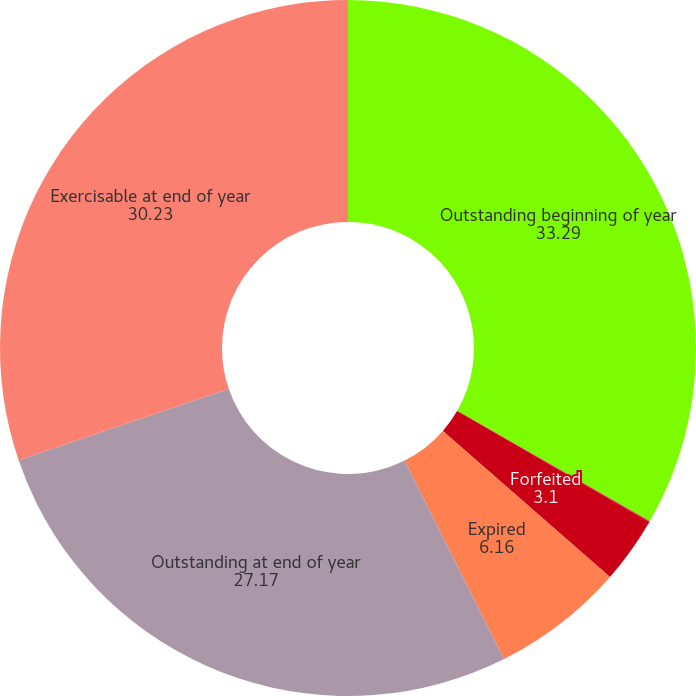<chart> <loc_0><loc_0><loc_500><loc_500><pie_chart><fcel>Outstanding beginning of year<fcel>Exercised<fcel>Forfeited<fcel>Expired<fcel>Outstanding at end of year<fcel>Exercisable at end of year<nl><fcel>33.29%<fcel>0.04%<fcel>3.1%<fcel>6.16%<fcel>27.17%<fcel>30.23%<nl></chart> 